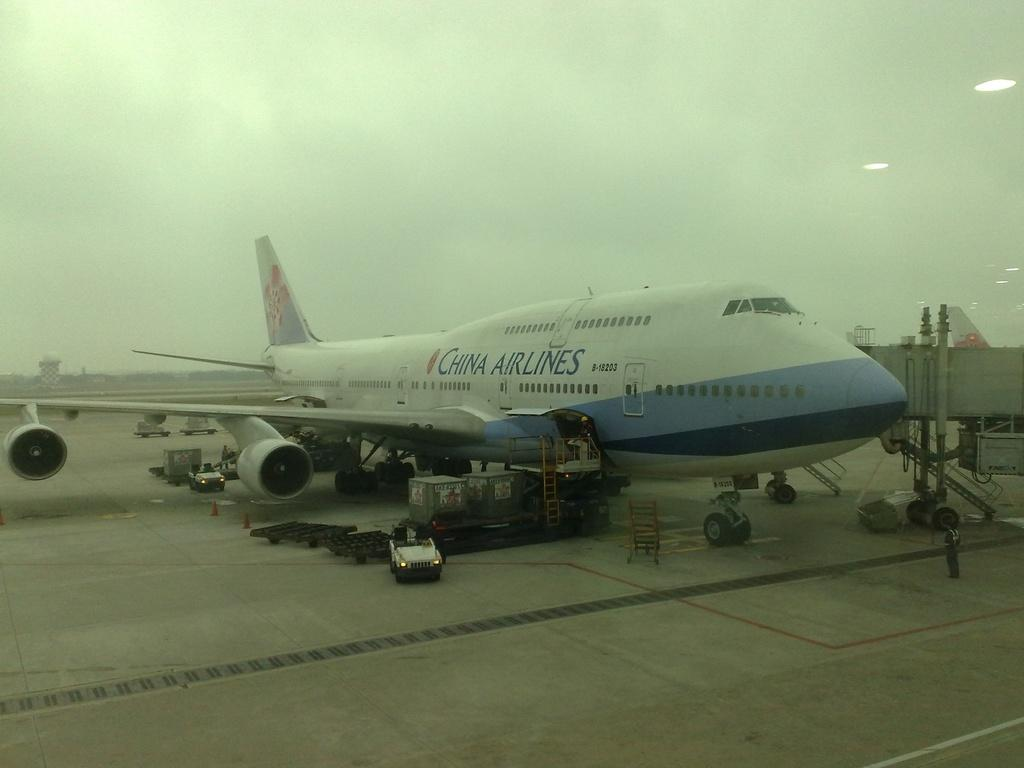<image>
Share a concise interpretation of the image provided. A large China Airlines plane sitting on the runway. 